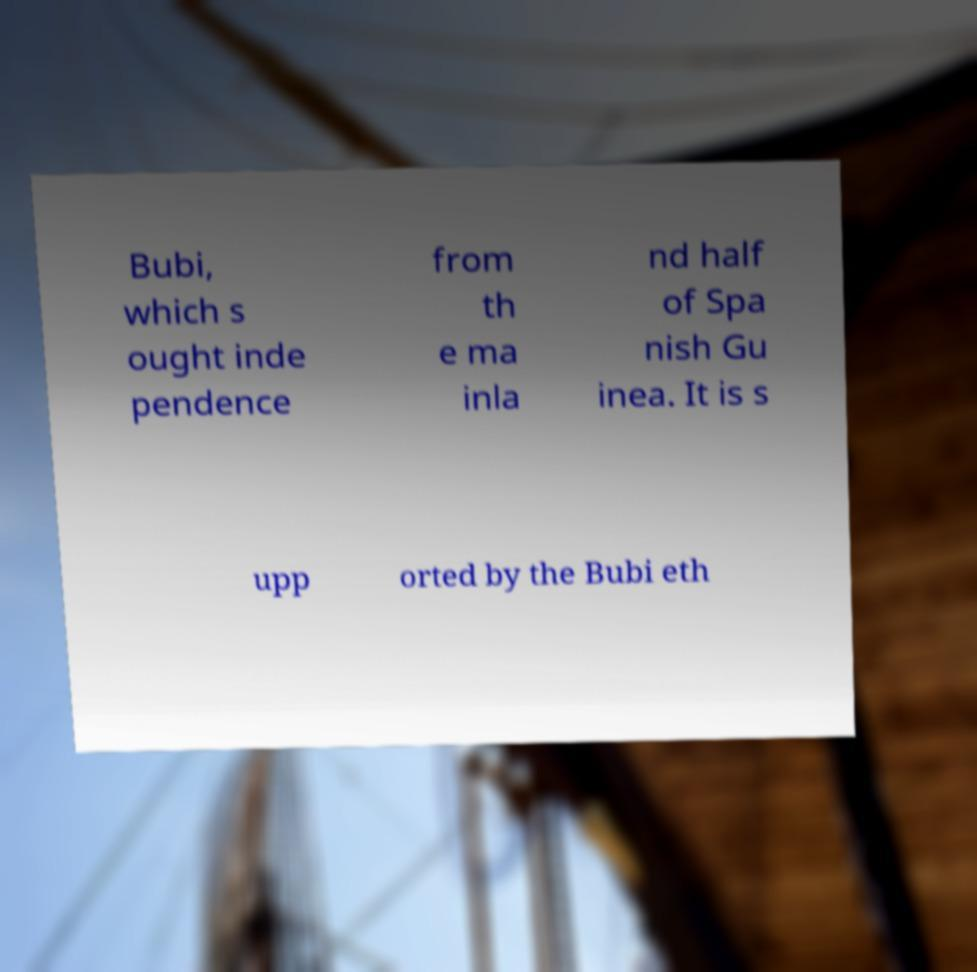Could you assist in decoding the text presented in this image and type it out clearly? Bubi, which s ought inde pendence from th e ma inla nd half of Spa nish Gu inea. It is s upp orted by the Bubi eth 